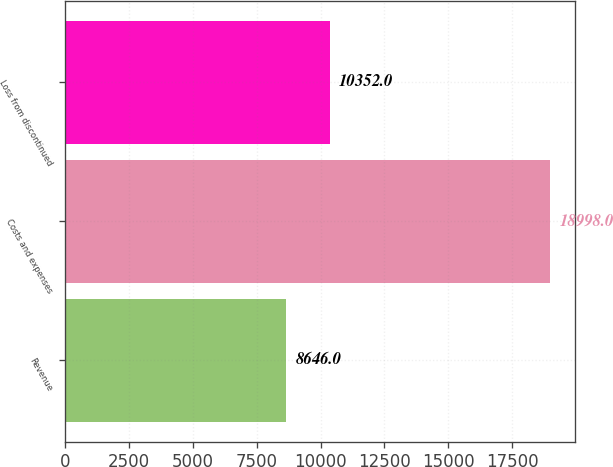Convert chart to OTSL. <chart><loc_0><loc_0><loc_500><loc_500><bar_chart><fcel>Revenue<fcel>Costs and expenses<fcel>Loss from discontinued<nl><fcel>8646<fcel>18998<fcel>10352<nl></chart> 